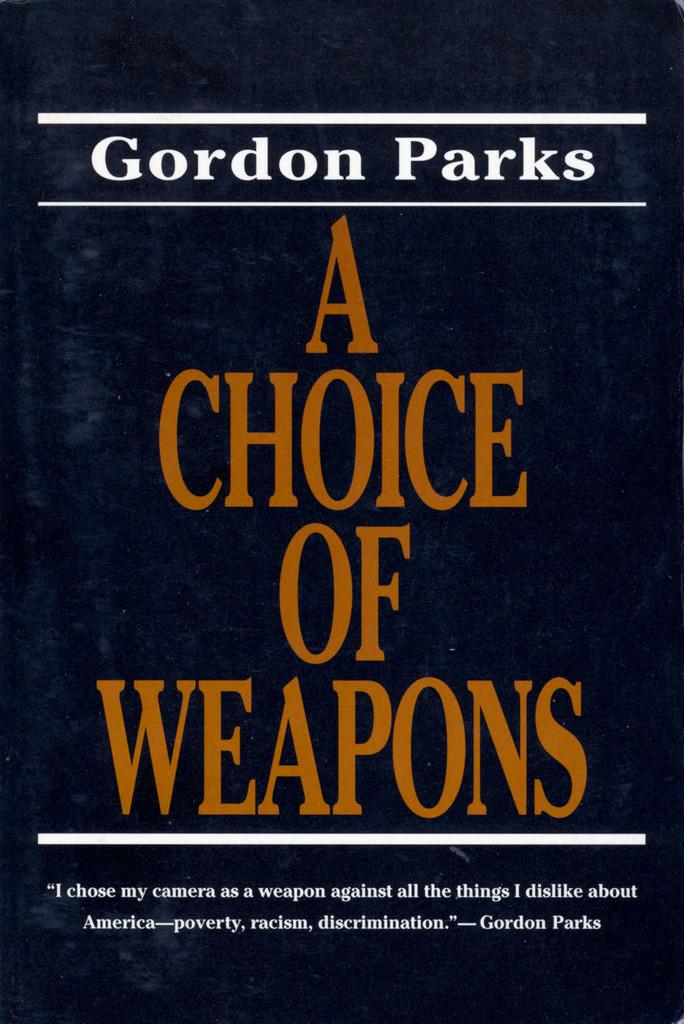What's the name of this book?
Provide a short and direct response. A choice of weapons. Who is the author?
Your answer should be very brief. Gordon parks. 